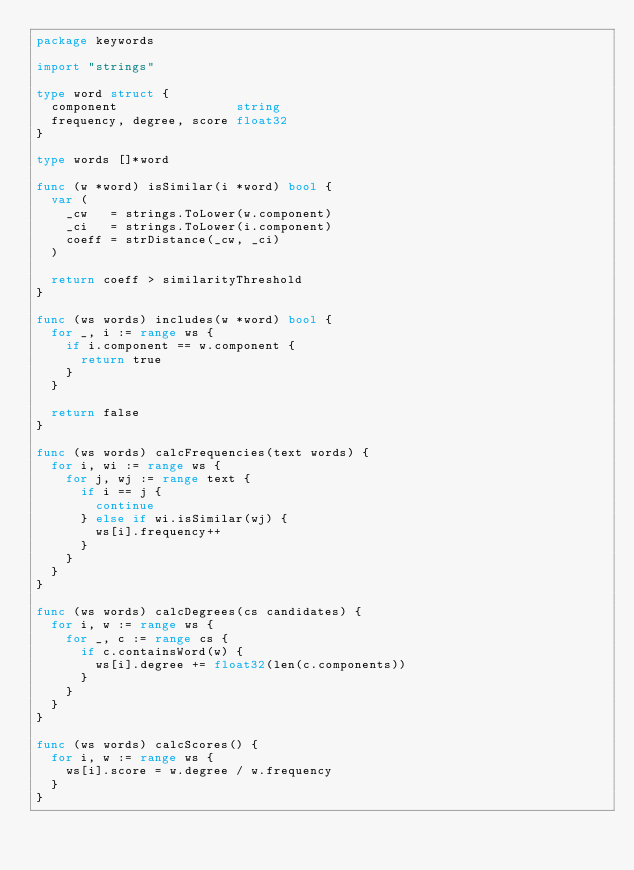<code> <loc_0><loc_0><loc_500><loc_500><_Go_>package keywords

import "strings"

type word struct {
	component                string
	frequency, degree, score float32
}

type words []*word

func (w *word) isSimilar(i *word) bool {
	var (
		_cw   = strings.ToLower(w.component)
		_ci   = strings.ToLower(i.component)
		coeff = strDistance(_cw, _ci)
	)

	return coeff > similarityThreshold
}

func (ws words) includes(w *word) bool {
	for _, i := range ws {
		if i.component == w.component {
			return true
		}
	}

	return false
}

func (ws words) calcFrequencies(text words) {
	for i, wi := range ws {
		for j, wj := range text {
			if i == j {
				continue
			} else if wi.isSimilar(wj) {
				ws[i].frequency++
			}
		}
	}
}

func (ws words) calcDegrees(cs candidates) {
	for i, w := range ws {
		for _, c := range cs {
			if c.containsWord(w) {
				ws[i].degree += float32(len(c.components))
			}
		}
	}
}

func (ws words) calcScores() {
	for i, w := range ws {
		ws[i].score = w.degree / w.frequency
	}
}
</code> 